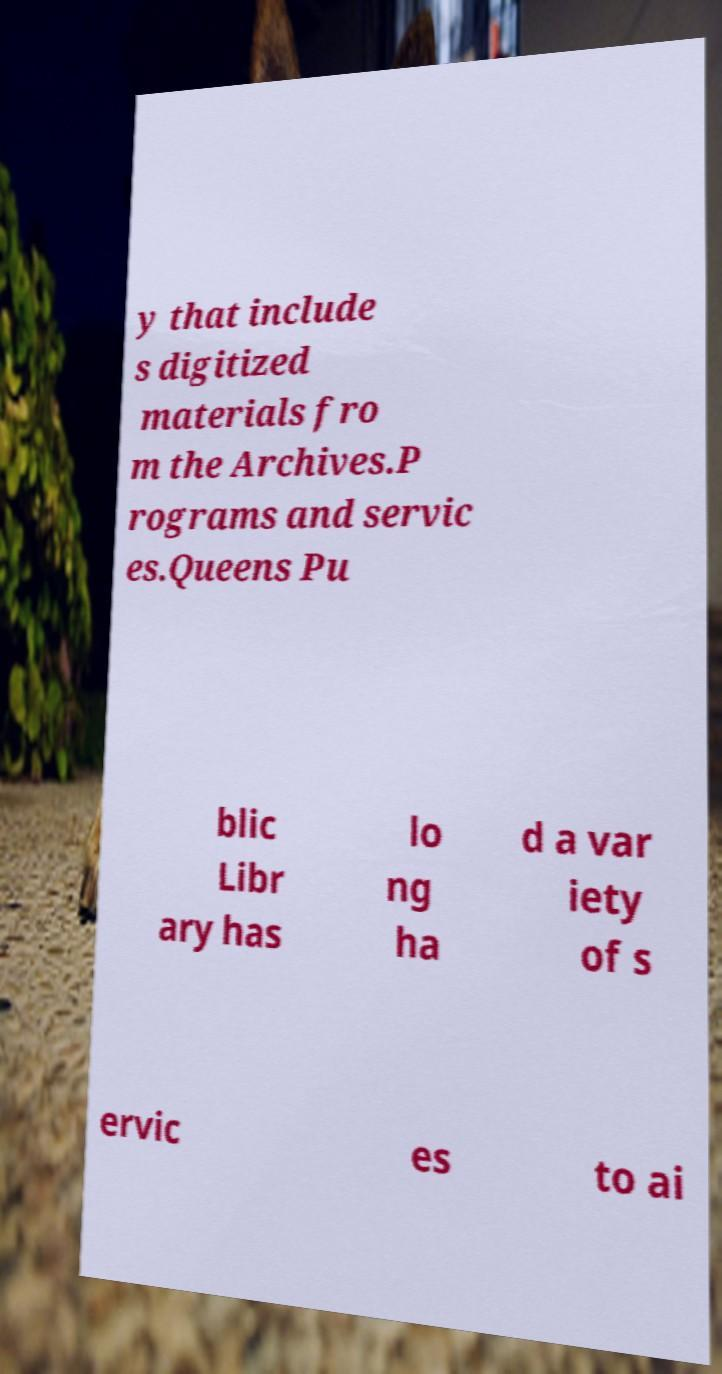There's text embedded in this image that I need extracted. Can you transcribe it verbatim? y that include s digitized materials fro m the Archives.P rograms and servic es.Queens Pu blic Libr ary has lo ng ha d a var iety of s ervic es to ai 